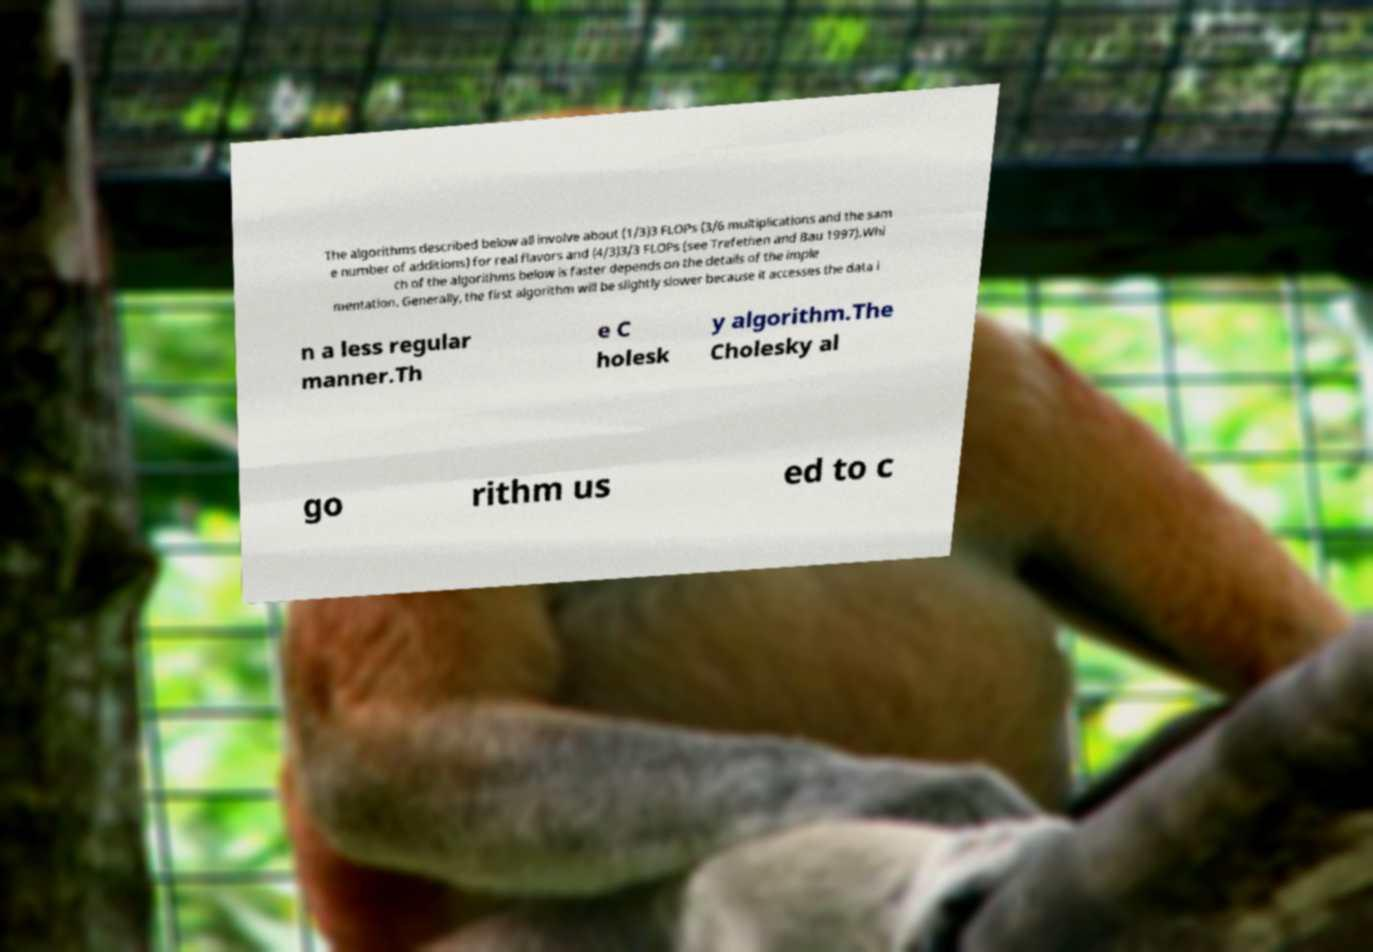What messages or text are displayed in this image? I need them in a readable, typed format. The algorithms described below all involve about (1/3)3 FLOPs (3/6 multiplications and the sam e number of additions) for real flavors and (4/3)3/3 FLOPs (see Trefethen and Bau 1997).Whi ch of the algorithms below is faster depends on the details of the imple mentation. Generally, the first algorithm will be slightly slower because it accesses the data i n a less regular manner.Th e C holesk y algorithm.The Cholesky al go rithm us ed to c 